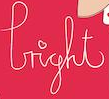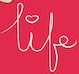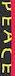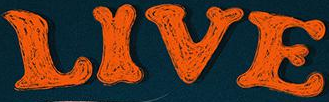Read the text from these images in sequence, separated by a semicolon. light; life; PEACE; LIVE 